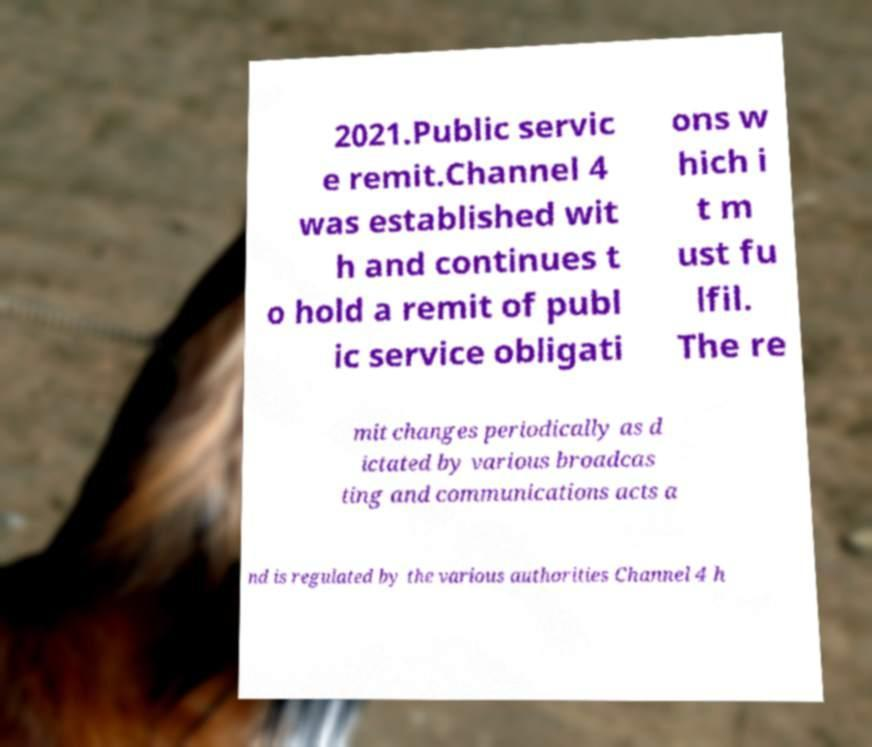There's text embedded in this image that I need extracted. Can you transcribe it verbatim? 2021.Public servic e remit.Channel 4 was established wit h and continues t o hold a remit of publ ic service obligati ons w hich i t m ust fu lfil. The re mit changes periodically as d ictated by various broadcas ting and communications acts a nd is regulated by the various authorities Channel 4 h 